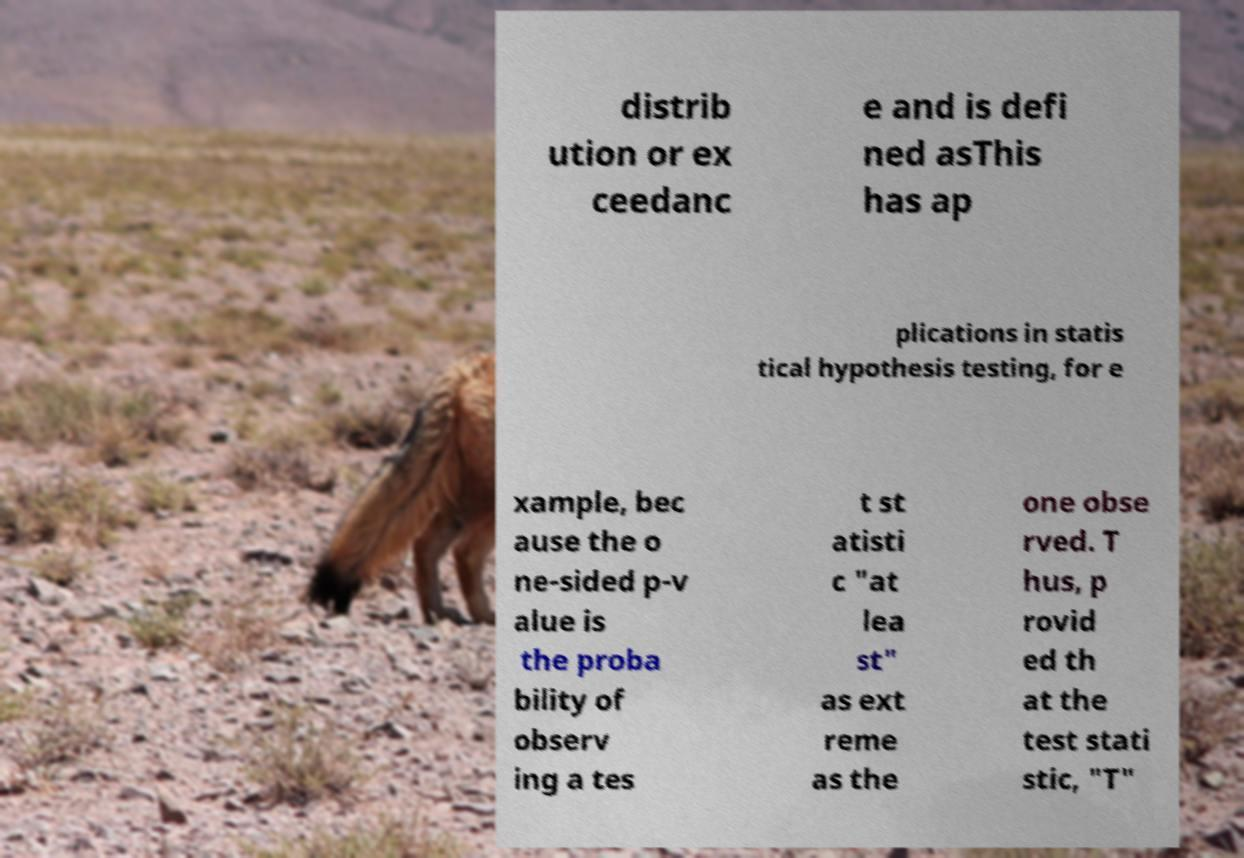Could you assist in decoding the text presented in this image and type it out clearly? distrib ution or ex ceedanc e and is defi ned asThis has ap plications in statis tical hypothesis testing, for e xample, bec ause the o ne-sided p-v alue is the proba bility of observ ing a tes t st atisti c "at lea st" as ext reme as the one obse rved. T hus, p rovid ed th at the test stati stic, "T" 